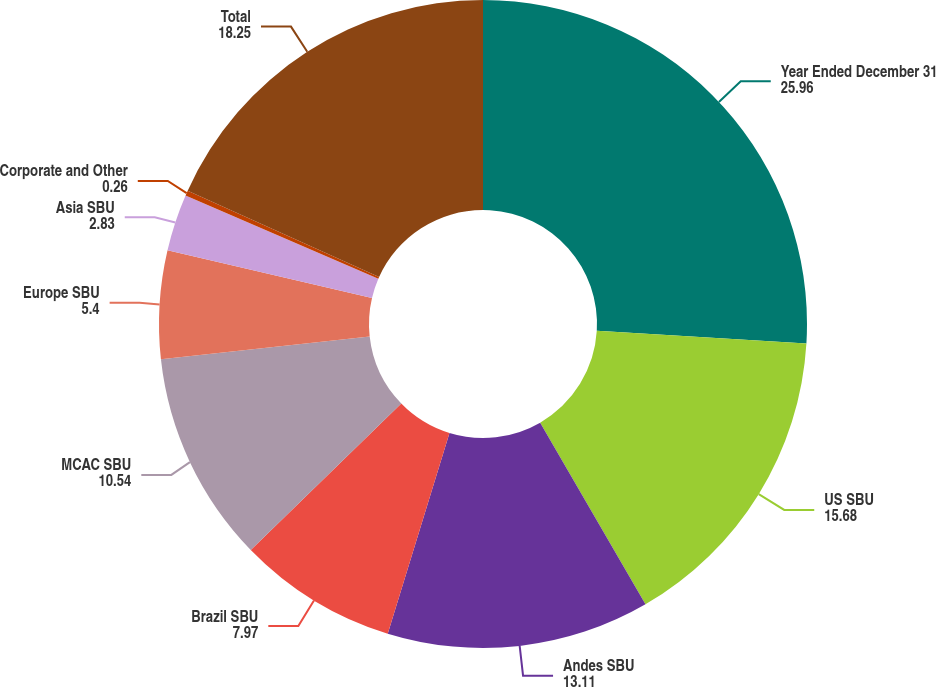Convert chart to OTSL. <chart><loc_0><loc_0><loc_500><loc_500><pie_chart><fcel>Year Ended December 31<fcel>US SBU<fcel>Andes SBU<fcel>Brazil SBU<fcel>MCAC SBU<fcel>Europe SBU<fcel>Asia SBU<fcel>Corporate and Other<fcel>Total<nl><fcel>25.96%<fcel>15.68%<fcel>13.11%<fcel>7.97%<fcel>10.54%<fcel>5.4%<fcel>2.83%<fcel>0.26%<fcel>18.25%<nl></chart> 